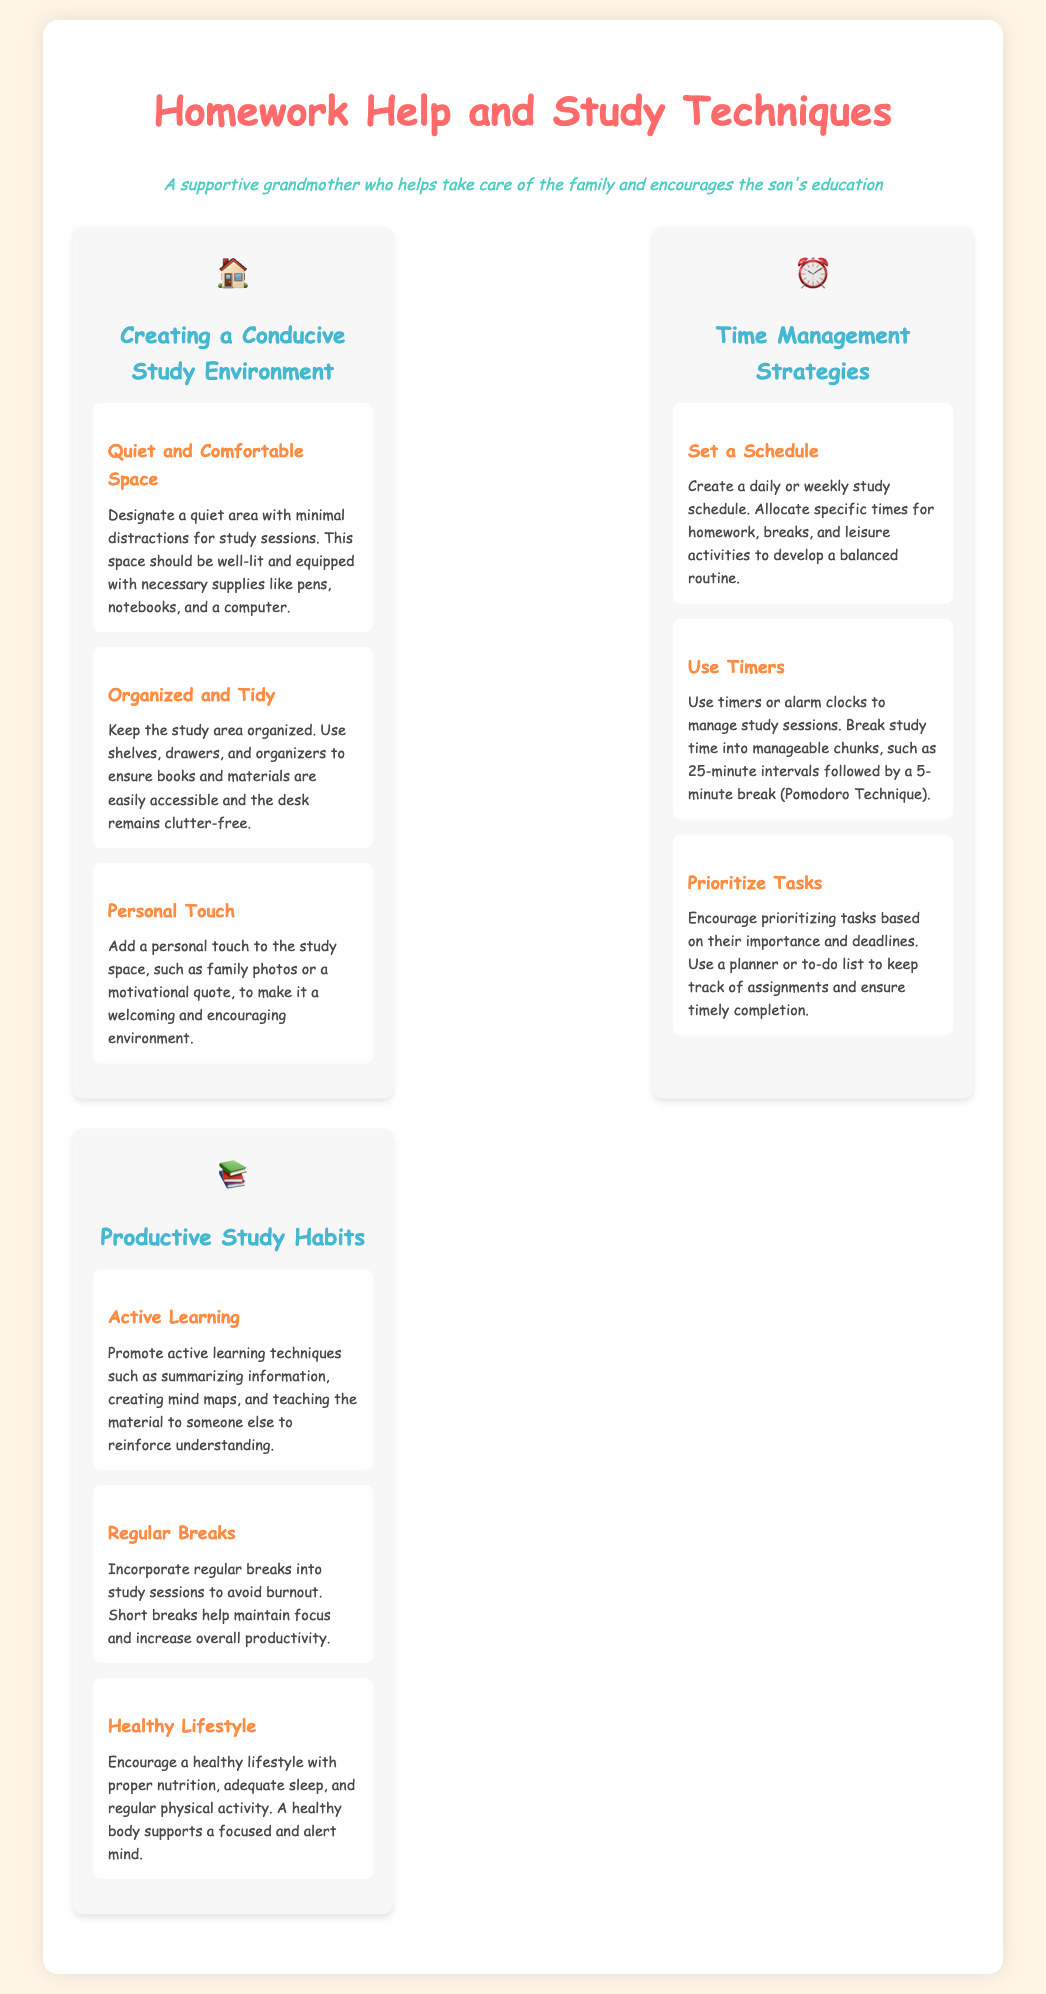What is the main title of the document? The main title is prominently featured at the top of the document and summarizes the focus of the content.
Answer: Homework Help and Study Techniques What section addresses study environment? This section is clearly marked in the document's layout, indicating the focus on creating an effective study space.
Answer: Creating a Conducive Study Environment How many process points are under "Time Management Strategies"? The number of process points in this section reflects the depth of strategies provided for effective time management.
Answer: 3 What technique is suggested for time management? This technique is explicitly mentioned in the time management section and is widely recognized for enhancing focus and productivity.
Answer: Pomodoro Technique What is a suggested active learning technique? This technique is mentioned under productive study habits to promote engagement with the material during study sessions.
Answer: Teaching the material to someone else What is the recommended space for studying? This description can be found in the document's first section, indicating an important aspect of where to study effectively.
Answer: Quiet area with minimal distractions What does the document recommend for maintaining focus? This recommendation is specific to enhancing concentration during study sessions through regular intervals.
Answer: Regular breaks What color is used for the section headings? This detail concerns the visual aspects of the document's design that help distinguish different sections.
Answer: #45B7D1 